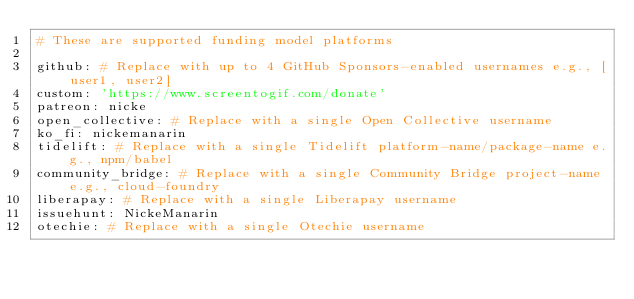<code> <loc_0><loc_0><loc_500><loc_500><_YAML_># These are supported funding model platforms

github: # Replace with up to 4 GitHub Sponsors-enabled usernames e.g., [user1, user2]
custom: 'https://www.screentogif.com/donate'
patreon: nicke
open_collective: # Replace with a single Open Collective username
ko_fi: nickemanarin
tidelift: # Replace with a single Tidelift platform-name/package-name e.g., npm/babel
community_bridge: # Replace with a single Community Bridge project-name e.g., cloud-foundry
liberapay: # Replace with a single Liberapay username
issuehunt: NickeManarin
otechie: # Replace with a single Otechie username
</code> 